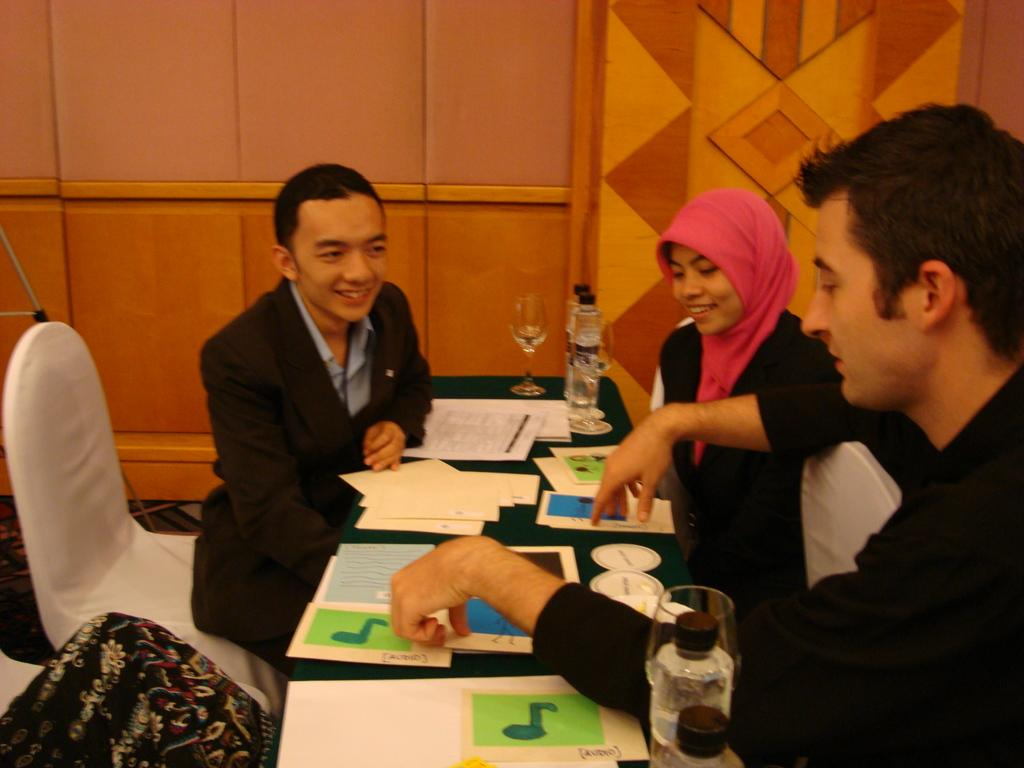How many people are seated in the image? There are three people seated in the image. What are the people seated on? The people are seated on chairs. What objects can be seen on the table in the image? There are papers, bottles, and glasses on the table. What type of joke can be seen in the image? There is no joke present in the image. Can you describe the waves in the image? There are no waves present in the image. 